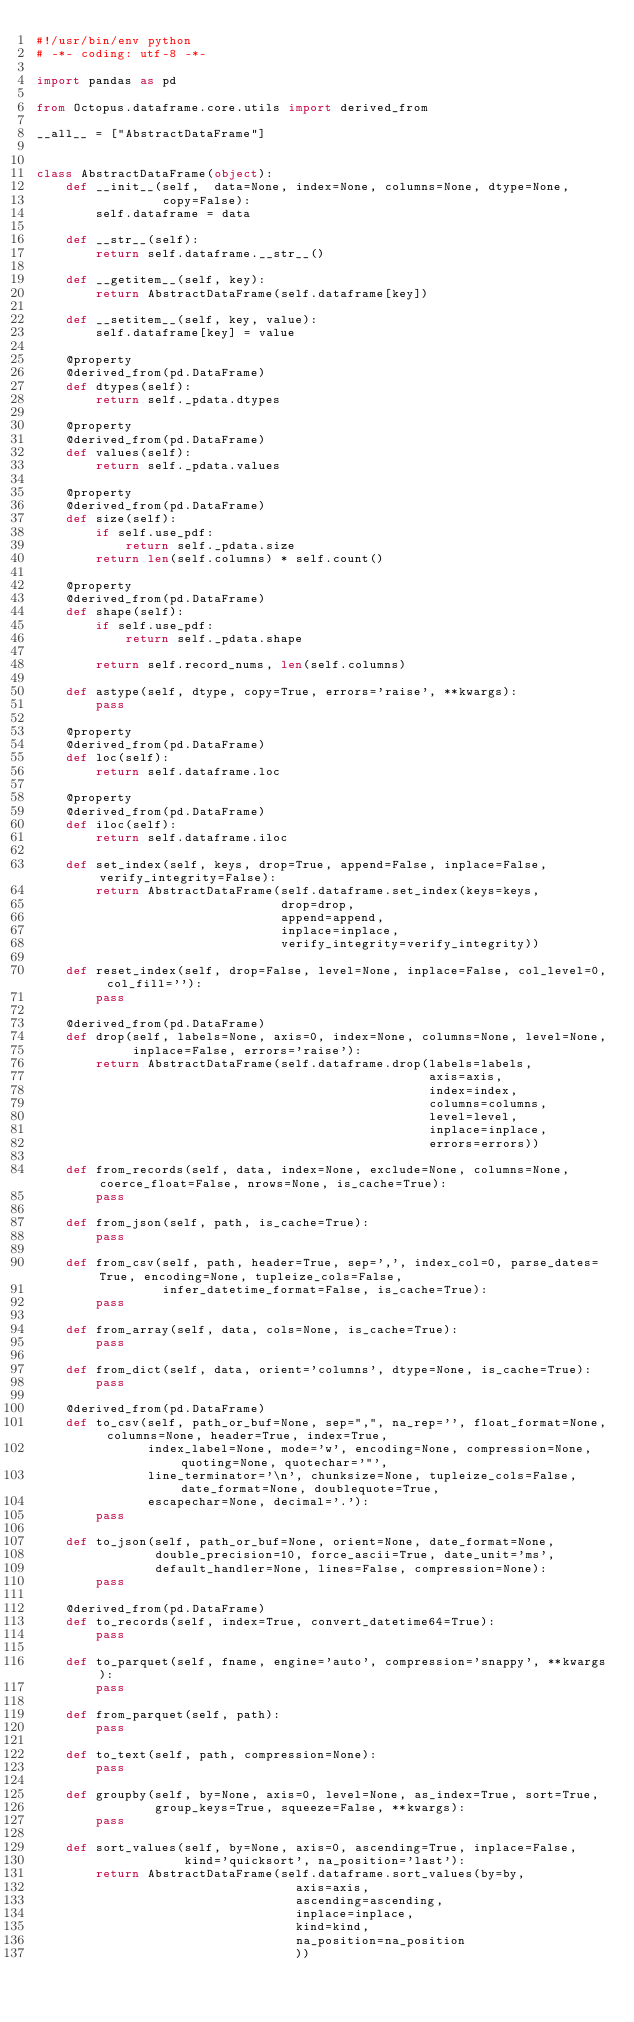<code> <loc_0><loc_0><loc_500><loc_500><_Python_>#!/usr/bin/env python
# -*- coding: utf-8 -*-

import pandas as pd

from Octopus.dataframe.core.utils import derived_from

__all__ = ["AbstractDataFrame"]


class AbstractDataFrame(object):
    def __init__(self,  data=None, index=None, columns=None, dtype=None,
                 copy=False):
        self.dataframe = data

    def __str__(self):
        return self.dataframe.__str__()

    def __getitem__(self, key):
        return AbstractDataFrame(self.dataframe[key])

    def __setitem__(self, key, value):
        self.dataframe[key] = value

    @property
    @derived_from(pd.DataFrame)
    def dtypes(self):
        return self._pdata.dtypes

    @property
    @derived_from(pd.DataFrame)
    def values(self):
        return self._pdata.values

    @property
    @derived_from(pd.DataFrame)
    def size(self):
        if self.use_pdf:
            return self._pdata.size
        return len(self.columns) * self.count()

    @property
    @derived_from(pd.DataFrame)
    def shape(self):
        if self.use_pdf:
            return self._pdata.shape

        return self.record_nums, len(self.columns)

    def astype(self, dtype, copy=True, errors='raise', **kwargs):
        pass

    @property
    @derived_from(pd.DataFrame)
    def loc(self):
        return self.dataframe.loc

    @property
    @derived_from(pd.DataFrame)
    def iloc(self):
        return self.dataframe.iloc

    def set_index(self, keys, drop=True, append=False, inplace=False, verify_integrity=False):
        return AbstractDataFrame(self.dataframe.set_index(keys=keys,
                                 drop=drop,
                                 append=append,
                                 inplace=inplace,
                                 verify_integrity=verify_integrity))

    def reset_index(self, drop=False, level=None, inplace=False, col_level=0, col_fill=''):
        pass

    @derived_from(pd.DataFrame)
    def drop(self, labels=None, axis=0, index=None, columns=None, level=None,
             inplace=False, errors='raise'):
        return AbstractDataFrame(self.dataframe.drop(labels=labels,
                                                     axis=axis,
                                                     index=index,
                                                     columns=columns,
                                                     level=level,
                                                     inplace=inplace,
                                                     errors=errors))

    def from_records(self, data, index=None, exclude=None, columns=None, coerce_float=False, nrows=None, is_cache=True):
        pass

    def from_json(self, path, is_cache=True):
        pass

    def from_csv(self, path, header=True, sep=',', index_col=0, parse_dates=True, encoding=None, tupleize_cols=False,
                 infer_datetime_format=False, is_cache=True):
        pass

    def from_array(self, data, cols=None, is_cache=True):
        pass

    def from_dict(self, data, orient='columns', dtype=None, is_cache=True):
        pass

    @derived_from(pd.DataFrame)
    def to_csv(self, path_or_buf=None, sep=",", na_rep='', float_format=None, columns=None, header=True, index=True,
               index_label=None, mode='w', encoding=None, compression=None, quoting=None, quotechar='"',
               line_terminator='\n', chunksize=None, tupleize_cols=False, date_format=None, doublequote=True,
               escapechar=None, decimal='.'):
        pass

    def to_json(self, path_or_buf=None, orient=None, date_format=None,
                double_precision=10, force_ascii=True, date_unit='ms',
                default_handler=None, lines=False, compression=None):
        pass

    @derived_from(pd.DataFrame)
    def to_records(self, index=True, convert_datetime64=True):
        pass

    def to_parquet(self, fname, engine='auto', compression='snappy', **kwargs):
        pass

    def from_parquet(self, path):
        pass

    def to_text(self, path, compression=None):
        pass

    def groupby(self, by=None, axis=0, level=None, as_index=True, sort=True,
                group_keys=True, squeeze=False, **kwargs):
        pass

    def sort_values(self, by=None, axis=0, ascending=True, inplace=False,
                    kind='quicksort', na_position='last'):
        return AbstractDataFrame(self.dataframe.sort_values(by=by,
                                   axis=axis,
                                   ascending=ascending,
                                   inplace=inplace,
                                   kind=kind,
                                   na_position=na_position
                                   ))
</code> 